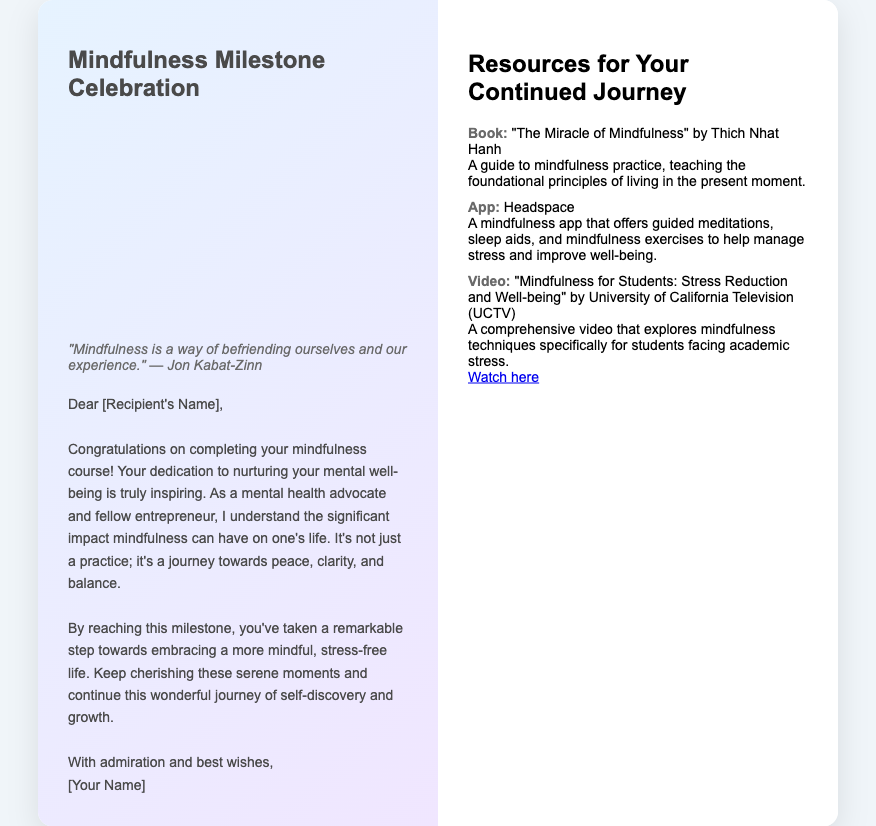What is the title of this greeting card? The title is prominently displayed at the top of the card, presenting the theme of the celebration.
Answer: Mindfulness Milestone Celebration Who is the quote attributed to? The quote included in the card is sourced from a well-known figure in mindfulness practice.
Answer: Jon Kabat-Zinn What color scheme is featured in this card? The calming aesthetics of the card can be identified through the background and panel colors.
Answer: Pastel colors What is the main message of the card? The message expresses congratulations for completing the mindfulness course and encourages continued practice and self-discovery.
Answer: Congratulations on completing your mindfulness course! What is one resource mentioned for continued mindfulness practice? The card lists resources to support ongoing mindfulness learning and practice.
Answer: The Miracle of Mindfulness How many panels does the card have? The structure of the card can be understood by the layout presented in the HTML document.
Answer: Two panels What is the background image theme? The nature scene used serves to convey a sense of calm and tranquility aligning with the card’s purpose.
Answer: Nature scene What is the purpose of the resources section? This section is designed to provide additional support and guidance for the recipient's mindfulness journey.
Answer: Continued journey What type of media is suggested in the resources? The resources section includes various types of media to enhance mindfulness practices for the recipient.
Answer: Book, App, Video 